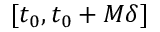<formula> <loc_0><loc_0><loc_500><loc_500>[ t _ { 0 } , t _ { 0 } + M \delta ]</formula> 